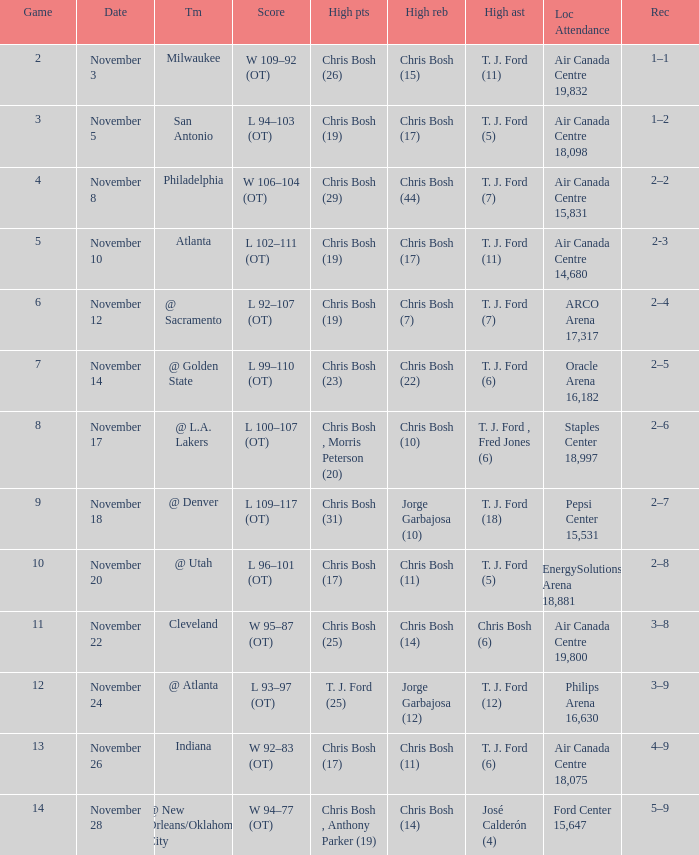Who scored the most points in game 4? Chris Bosh (29). 